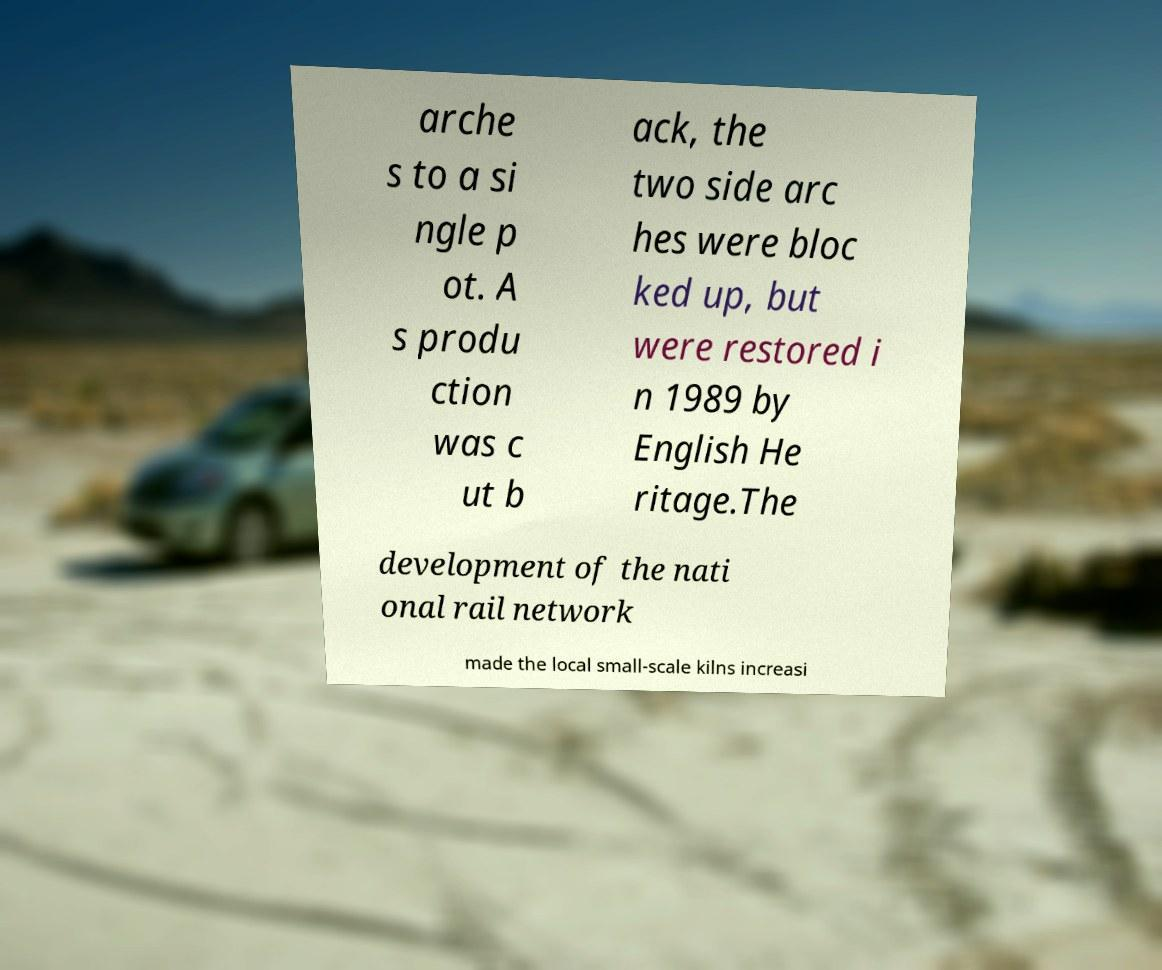I need the written content from this picture converted into text. Can you do that? arche s to a si ngle p ot. A s produ ction was c ut b ack, the two side arc hes were bloc ked up, but were restored i n 1989 by English He ritage.The development of the nati onal rail network made the local small-scale kilns increasi 